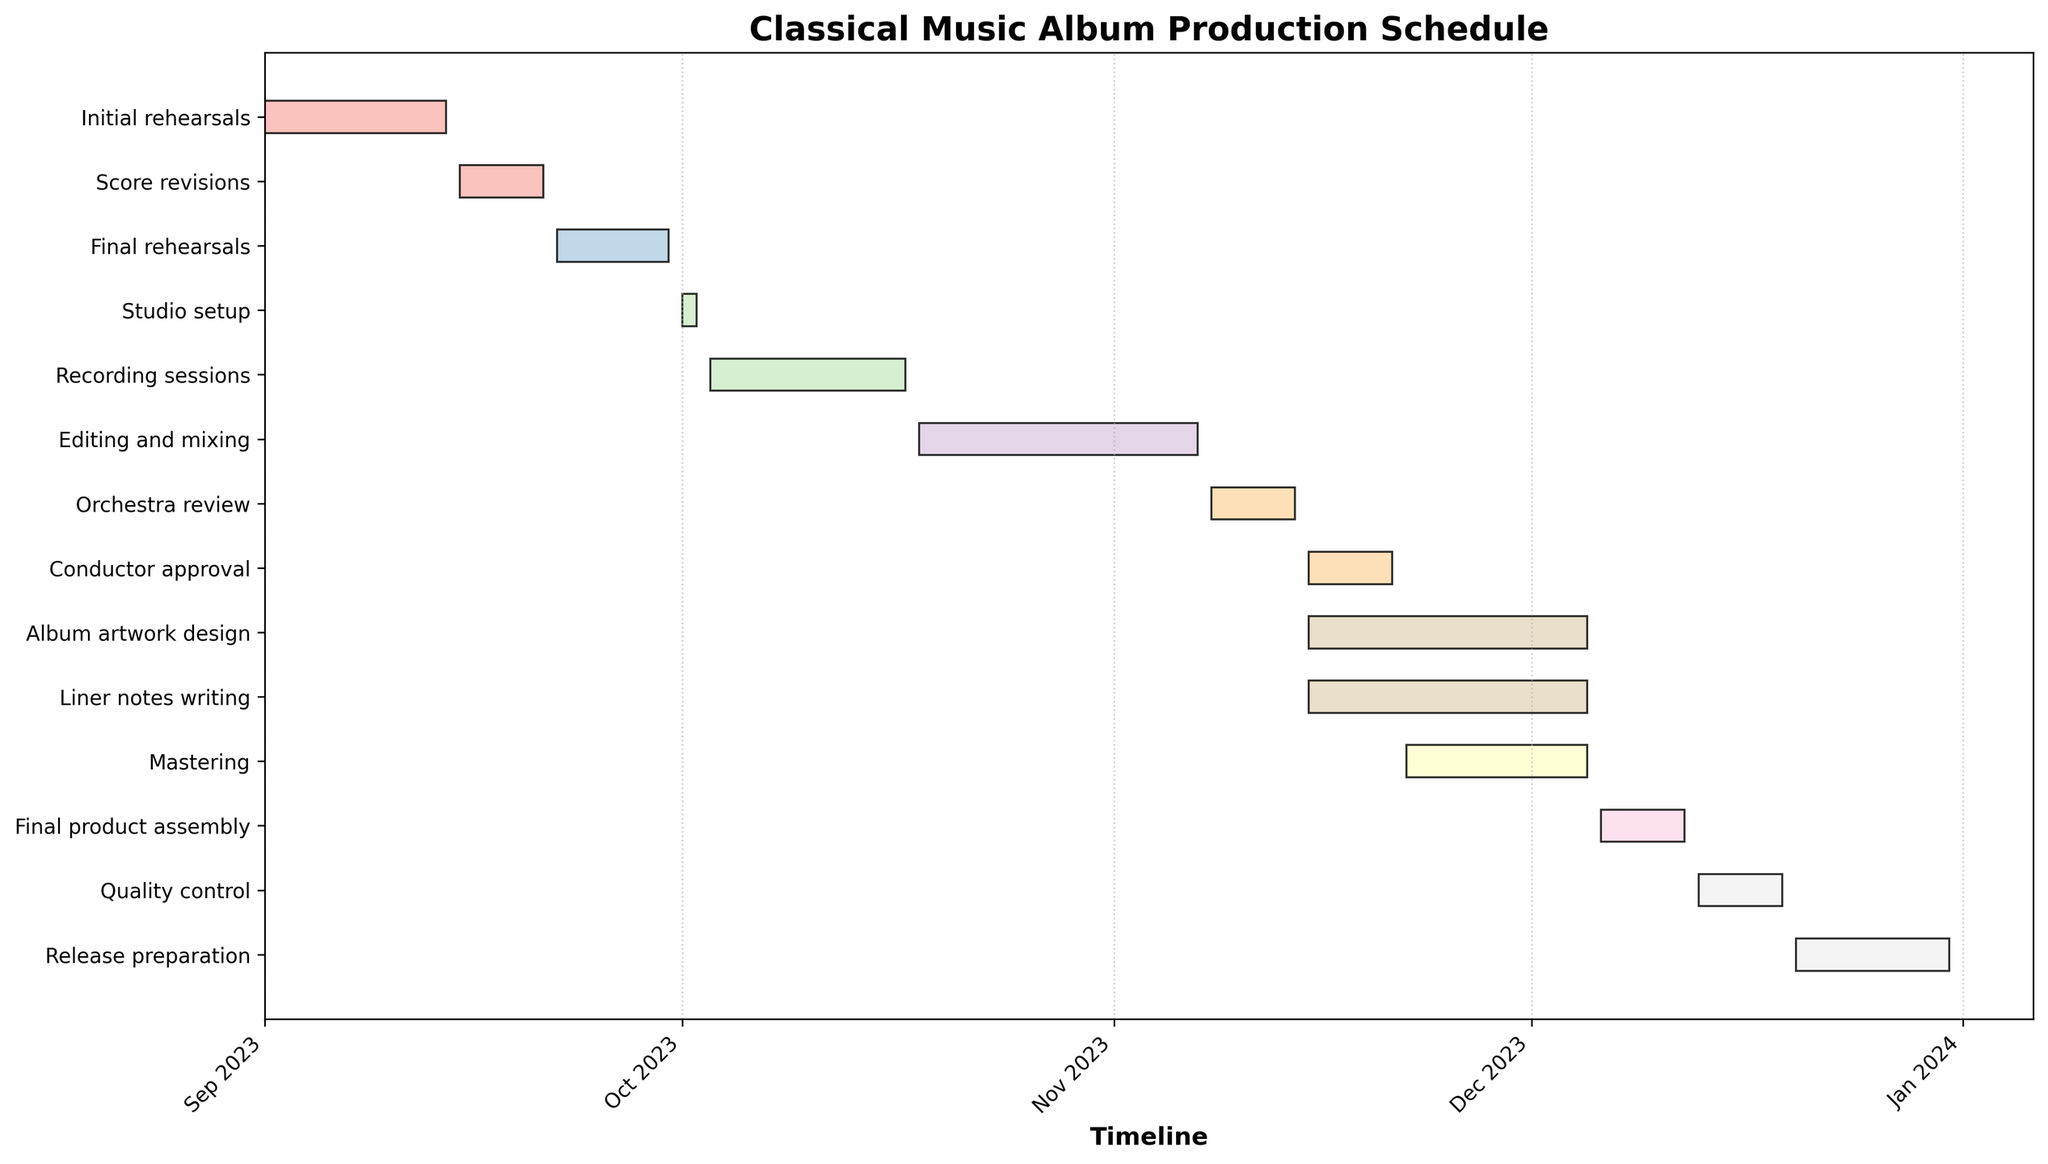When does the "Recording sessions" start and end? According to the Gantt chart, each task has a start and end date listed next to it. The "Recording sessions" start on 2023-10-03 and end on 2023-10-17.
Answer: 2023-10-03 to 2023-10-17 Which task follows "Final rehearsals"? The tasks are sequenced by their time periods. The task following "Final rehearsals" is "Studio setup".
Answer: Studio setup How long does the "Editing and mixing" process take? The duration of each task can be calculated by subtracting the start date from the end date. "Editing and mixing" begins on 2023-10-18 and ends on 2023-11-07, resulting in a duration of 21 days.
Answer: 21 days What tasks are performed concurrently with "Album artwork design"? Checking the Gantt chart for overlapping time periods, "Liner notes writing" and "Mastering" are performed concurrently with "Album artwork design".
Answer: Liner notes writing, Mastering Which task takes the longest time to complete? The durations can be compared by examining the length of the bars. "Editing and mixing" has the longest duration from 2023-10-18 to 2023-11-07, lasting 21 days.
Answer: Editing and mixing How does the duration of "Final product assembly" compare to "Quality control"? "Final product assembly" runs from 2023-12-06 to 2023-12-12, totaling 7 days, whereas "Quality control" runs from 2023-12-13 to 2023-12-19, also totaling 7 days. Therefore, their durations are equal.
Answer: Equal What is the time gap between the end of "Conductor approval" and the start of "Mastering"? "Conductor approval" ends on 2023-11-21, and "Mastering" starts on 2023-11-22, indicating a time gap of 1 day.
Answer: 1 day If some delay occurs in "Recording sessions", which subsequent tasks might be affected? Any delay in "Recording sessions" would affect tasks that start shortly after it. "Editing and mixing," which starts immediately after "Recording sessions," would be directly affected.
Answer: Editing and mixing How many tasks overlap with "Release preparation"? "Release preparation" runs from 2023-12-20 to 2023-12-31. Checking these dates, no other tasks overlap with this time period, as it is the final task on the chart.
Answer: None If "Initial rehearsals" start one week later than planned, how would that affect the entire schedule? A delay in "Initial rehearsals" would push all subsequent tasks forward by one week. This domino effect would push the entire schedule forward, delaying the final release as well. The new start date for each task would be one week later than originally planned.
Answer: Schedule delayed by one week 